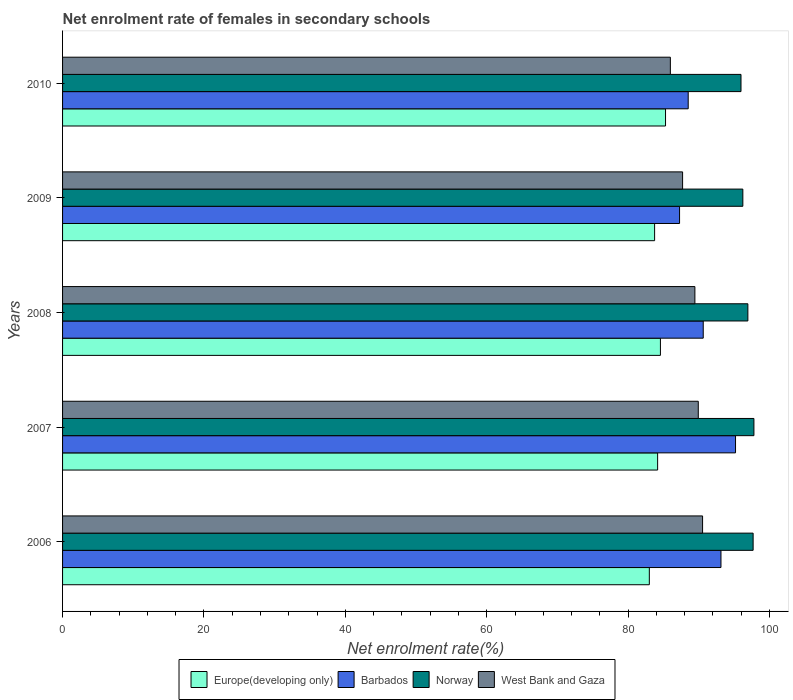How many different coloured bars are there?
Provide a succinct answer. 4. How many groups of bars are there?
Your answer should be compact. 5. Are the number of bars per tick equal to the number of legend labels?
Provide a succinct answer. Yes. Are the number of bars on each tick of the Y-axis equal?
Your response must be concise. Yes. How many bars are there on the 4th tick from the top?
Offer a very short reply. 4. What is the label of the 1st group of bars from the top?
Your response must be concise. 2010. In how many cases, is the number of bars for a given year not equal to the number of legend labels?
Provide a short and direct response. 0. What is the net enrolment rate of females in secondary schools in West Bank and Gaza in 2007?
Your answer should be compact. 89.92. Across all years, what is the maximum net enrolment rate of females in secondary schools in Norway?
Your answer should be compact. 97.79. Across all years, what is the minimum net enrolment rate of females in secondary schools in West Bank and Gaza?
Offer a terse response. 85.97. In which year was the net enrolment rate of females in secondary schools in Norway maximum?
Keep it short and to the point. 2007. In which year was the net enrolment rate of females in secondary schools in Europe(developing only) minimum?
Your answer should be very brief. 2006. What is the total net enrolment rate of females in secondary schools in Norway in the graph?
Give a very brief answer. 484.61. What is the difference between the net enrolment rate of females in secondary schools in West Bank and Gaza in 2006 and that in 2009?
Keep it short and to the point. 2.83. What is the difference between the net enrolment rate of females in secondary schools in Europe(developing only) in 2006 and the net enrolment rate of females in secondary schools in Norway in 2008?
Provide a short and direct response. -13.94. What is the average net enrolment rate of females in secondary schools in Norway per year?
Your response must be concise. 96.92. In the year 2008, what is the difference between the net enrolment rate of females in secondary schools in Barbados and net enrolment rate of females in secondary schools in West Bank and Gaza?
Make the answer very short. 1.18. In how many years, is the net enrolment rate of females in secondary schools in West Bank and Gaza greater than 12 %?
Give a very brief answer. 5. What is the ratio of the net enrolment rate of females in secondary schools in Norway in 2008 to that in 2009?
Give a very brief answer. 1.01. Is the difference between the net enrolment rate of females in secondary schools in Barbados in 2006 and 2010 greater than the difference between the net enrolment rate of females in secondary schools in West Bank and Gaza in 2006 and 2010?
Give a very brief answer. Yes. What is the difference between the highest and the second highest net enrolment rate of females in secondary schools in Europe(developing only)?
Offer a very short reply. 0.72. What is the difference between the highest and the lowest net enrolment rate of females in secondary schools in Norway?
Your answer should be compact. 1.83. In how many years, is the net enrolment rate of females in secondary schools in Barbados greater than the average net enrolment rate of females in secondary schools in Barbados taken over all years?
Give a very brief answer. 2. Is the sum of the net enrolment rate of females in secondary schools in Norway in 2008 and 2009 greater than the maximum net enrolment rate of females in secondary schools in Barbados across all years?
Provide a short and direct response. Yes. Is it the case that in every year, the sum of the net enrolment rate of females in secondary schools in Barbados and net enrolment rate of females in secondary schools in Norway is greater than the sum of net enrolment rate of females in secondary schools in West Bank and Gaza and net enrolment rate of females in secondary schools in Europe(developing only)?
Your response must be concise. Yes. What does the 2nd bar from the top in 2009 represents?
Keep it short and to the point. Norway. What does the 2nd bar from the bottom in 2010 represents?
Provide a short and direct response. Barbados. How many bars are there?
Ensure brevity in your answer.  20. How many legend labels are there?
Make the answer very short. 4. What is the title of the graph?
Ensure brevity in your answer.  Net enrolment rate of females in secondary schools. Does "Pacific island small states" appear as one of the legend labels in the graph?
Make the answer very short. No. What is the label or title of the X-axis?
Keep it short and to the point. Net enrolment rate(%). What is the label or title of the Y-axis?
Offer a very short reply. Years. What is the Net enrolment rate(%) in Europe(developing only) in 2006?
Make the answer very short. 83. What is the Net enrolment rate(%) of Barbados in 2006?
Your answer should be compact. 93.13. What is the Net enrolment rate(%) of Norway in 2006?
Your answer should be very brief. 97.68. What is the Net enrolment rate(%) of West Bank and Gaza in 2006?
Make the answer very short. 90.53. What is the Net enrolment rate(%) of Europe(developing only) in 2007?
Your response must be concise. 84.17. What is the Net enrolment rate(%) in Barbados in 2007?
Offer a terse response. 95.19. What is the Net enrolment rate(%) of Norway in 2007?
Provide a succinct answer. 97.79. What is the Net enrolment rate(%) of West Bank and Gaza in 2007?
Offer a very short reply. 89.92. What is the Net enrolment rate(%) of Europe(developing only) in 2008?
Make the answer very short. 84.57. What is the Net enrolment rate(%) of Barbados in 2008?
Give a very brief answer. 90.63. What is the Net enrolment rate(%) in Norway in 2008?
Provide a succinct answer. 96.94. What is the Net enrolment rate(%) in West Bank and Gaza in 2008?
Keep it short and to the point. 89.44. What is the Net enrolment rate(%) in Europe(developing only) in 2009?
Offer a terse response. 83.75. What is the Net enrolment rate(%) of Barbados in 2009?
Provide a short and direct response. 87.28. What is the Net enrolment rate(%) in Norway in 2009?
Give a very brief answer. 96.23. What is the Net enrolment rate(%) of West Bank and Gaza in 2009?
Keep it short and to the point. 87.71. What is the Net enrolment rate(%) of Europe(developing only) in 2010?
Provide a short and direct response. 85.29. What is the Net enrolment rate(%) of Barbados in 2010?
Your answer should be very brief. 88.5. What is the Net enrolment rate(%) in Norway in 2010?
Provide a short and direct response. 95.97. What is the Net enrolment rate(%) of West Bank and Gaza in 2010?
Keep it short and to the point. 85.97. Across all years, what is the maximum Net enrolment rate(%) of Europe(developing only)?
Provide a short and direct response. 85.29. Across all years, what is the maximum Net enrolment rate(%) in Barbados?
Make the answer very short. 95.19. Across all years, what is the maximum Net enrolment rate(%) in Norway?
Offer a terse response. 97.79. Across all years, what is the maximum Net enrolment rate(%) of West Bank and Gaza?
Ensure brevity in your answer.  90.53. Across all years, what is the minimum Net enrolment rate(%) in Europe(developing only)?
Offer a terse response. 83. Across all years, what is the minimum Net enrolment rate(%) in Barbados?
Your response must be concise. 87.28. Across all years, what is the minimum Net enrolment rate(%) in Norway?
Provide a short and direct response. 95.97. Across all years, what is the minimum Net enrolment rate(%) of West Bank and Gaza?
Your response must be concise. 85.97. What is the total Net enrolment rate(%) in Europe(developing only) in the graph?
Your answer should be compact. 420.78. What is the total Net enrolment rate(%) in Barbados in the graph?
Provide a short and direct response. 454.72. What is the total Net enrolment rate(%) in Norway in the graph?
Give a very brief answer. 484.61. What is the total Net enrolment rate(%) in West Bank and Gaza in the graph?
Keep it short and to the point. 443.58. What is the difference between the Net enrolment rate(%) in Europe(developing only) in 2006 and that in 2007?
Your response must be concise. -1.17. What is the difference between the Net enrolment rate(%) of Barbados in 2006 and that in 2007?
Offer a very short reply. -2.06. What is the difference between the Net enrolment rate(%) in Norway in 2006 and that in 2007?
Keep it short and to the point. -0.11. What is the difference between the Net enrolment rate(%) of West Bank and Gaza in 2006 and that in 2007?
Your answer should be compact. 0.61. What is the difference between the Net enrolment rate(%) of Europe(developing only) in 2006 and that in 2008?
Offer a very short reply. -1.57. What is the difference between the Net enrolment rate(%) of Barbados in 2006 and that in 2008?
Offer a very short reply. 2.51. What is the difference between the Net enrolment rate(%) of Norway in 2006 and that in 2008?
Give a very brief answer. 0.74. What is the difference between the Net enrolment rate(%) of West Bank and Gaza in 2006 and that in 2008?
Keep it short and to the point. 1.09. What is the difference between the Net enrolment rate(%) of Europe(developing only) in 2006 and that in 2009?
Keep it short and to the point. -0.75. What is the difference between the Net enrolment rate(%) in Barbados in 2006 and that in 2009?
Provide a succinct answer. 5.86. What is the difference between the Net enrolment rate(%) in Norway in 2006 and that in 2009?
Provide a short and direct response. 1.46. What is the difference between the Net enrolment rate(%) in West Bank and Gaza in 2006 and that in 2009?
Provide a succinct answer. 2.83. What is the difference between the Net enrolment rate(%) in Europe(developing only) in 2006 and that in 2010?
Ensure brevity in your answer.  -2.29. What is the difference between the Net enrolment rate(%) of Barbados in 2006 and that in 2010?
Ensure brevity in your answer.  4.63. What is the difference between the Net enrolment rate(%) in Norway in 2006 and that in 2010?
Give a very brief answer. 1.72. What is the difference between the Net enrolment rate(%) of West Bank and Gaza in 2006 and that in 2010?
Offer a very short reply. 4.56. What is the difference between the Net enrolment rate(%) of Europe(developing only) in 2007 and that in 2008?
Provide a short and direct response. -0.4. What is the difference between the Net enrolment rate(%) in Barbados in 2007 and that in 2008?
Your answer should be compact. 4.57. What is the difference between the Net enrolment rate(%) of Norway in 2007 and that in 2008?
Offer a very short reply. 0.86. What is the difference between the Net enrolment rate(%) of West Bank and Gaza in 2007 and that in 2008?
Provide a short and direct response. 0.48. What is the difference between the Net enrolment rate(%) of Europe(developing only) in 2007 and that in 2009?
Your answer should be very brief. 0.43. What is the difference between the Net enrolment rate(%) in Barbados in 2007 and that in 2009?
Provide a succinct answer. 7.92. What is the difference between the Net enrolment rate(%) of Norway in 2007 and that in 2009?
Give a very brief answer. 1.57. What is the difference between the Net enrolment rate(%) in West Bank and Gaza in 2007 and that in 2009?
Provide a short and direct response. 2.22. What is the difference between the Net enrolment rate(%) of Europe(developing only) in 2007 and that in 2010?
Offer a very short reply. -1.12. What is the difference between the Net enrolment rate(%) of Barbados in 2007 and that in 2010?
Provide a short and direct response. 6.69. What is the difference between the Net enrolment rate(%) in Norway in 2007 and that in 2010?
Offer a terse response. 1.83. What is the difference between the Net enrolment rate(%) in West Bank and Gaza in 2007 and that in 2010?
Make the answer very short. 3.95. What is the difference between the Net enrolment rate(%) of Europe(developing only) in 2008 and that in 2009?
Your answer should be compact. 0.82. What is the difference between the Net enrolment rate(%) in Barbados in 2008 and that in 2009?
Your response must be concise. 3.35. What is the difference between the Net enrolment rate(%) in Norway in 2008 and that in 2009?
Keep it short and to the point. 0.71. What is the difference between the Net enrolment rate(%) of West Bank and Gaza in 2008 and that in 2009?
Your response must be concise. 1.74. What is the difference between the Net enrolment rate(%) of Europe(developing only) in 2008 and that in 2010?
Ensure brevity in your answer.  -0.72. What is the difference between the Net enrolment rate(%) in Barbados in 2008 and that in 2010?
Keep it short and to the point. 2.13. What is the difference between the Net enrolment rate(%) in Norway in 2008 and that in 2010?
Offer a very short reply. 0.97. What is the difference between the Net enrolment rate(%) in West Bank and Gaza in 2008 and that in 2010?
Your answer should be very brief. 3.47. What is the difference between the Net enrolment rate(%) in Europe(developing only) in 2009 and that in 2010?
Provide a short and direct response. -1.54. What is the difference between the Net enrolment rate(%) in Barbados in 2009 and that in 2010?
Your answer should be compact. -1.22. What is the difference between the Net enrolment rate(%) of Norway in 2009 and that in 2010?
Offer a very short reply. 0.26. What is the difference between the Net enrolment rate(%) of West Bank and Gaza in 2009 and that in 2010?
Give a very brief answer. 1.73. What is the difference between the Net enrolment rate(%) of Europe(developing only) in 2006 and the Net enrolment rate(%) of Barbados in 2007?
Make the answer very short. -12.19. What is the difference between the Net enrolment rate(%) of Europe(developing only) in 2006 and the Net enrolment rate(%) of Norway in 2007?
Make the answer very short. -14.79. What is the difference between the Net enrolment rate(%) of Europe(developing only) in 2006 and the Net enrolment rate(%) of West Bank and Gaza in 2007?
Offer a very short reply. -6.93. What is the difference between the Net enrolment rate(%) of Barbados in 2006 and the Net enrolment rate(%) of Norway in 2007?
Offer a terse response. -4.66. What is the difference between the Net enrolment rate(%) in Barbados in 2006 and the Net enrolment rate(%) in West Bank and Gaza in 2007?
Give a very brief answer. 3.21. What is the difference between the Net enrolment rate(%) of Norway in 2006 and the Net enrolment rate(%) of West Bank and Gaza in 2007?
Ensure brevity in your answer.  7.76. What is the difference between the Net enrolment rate(%) in Europe(developing only) in 2006 and the Net enrolment rate(%) in Barbados in 2008?
Make the answer very short. -7.63. What is the difference between the Net enrolment rate(%) of Europe(developing only) in 2006 and the Net enrolment rate(%) of Norway in 2008?
Your answer should be very brief. -13.94. What is the difference between the Net enrolment rate(%) of Europe(developing only) in 2006 and the Net enrolment rate(%) of West Bank and Gaza in 2008?
Make the answer very short. -6.44. What is the difference between the Net enrolment rate(%) of Barbados in 2006 and the Net enrolment rate(%) of Norway in 2008?
Make the answer very short. -3.81. What is the difference between the Net enrolment rate(%) in Barbados in 2006 and the Net enrolment rate(%) in West Bank and Gaza in 2008?
Make the answer very short. 3.69. What is the difference between the Net enrolment rate(%) in Norway in 2006 and the Net enrolment rate(%) in West Bank and Gaza in 2008?
Ensure brevity in your answer.  8.24. What is the difference between the Net enrolment rate(%) in Europe(developing only) in 2006 and the Net enrolment rate(%) in Barbados in 2009?
Your response must be concise. -4.28. What is the difference between the Net enrolment rate(%) in Europe(developing only) in 2006 and the Net enrolment rate(%) in Norway in 2009?
Make the answer very short. -13.23. What is the difference between the Net enrolment rate(%) of Europe(developing only) in 2006 and the Net enrolment rate(%) of West Bank and Gaza in 2009?
Offer a terse response. -4.71. What is the difference between the Net enrolment rate(%) in Barbados in 2006 and the Net enrolment rate(%) in Norway in 2009?
Your response must be concise. -3.09. What is the difference between the Net enrolment rate(%) in Barbados in 2006 and the Net enrolment rate(%) in West Bank and Gaza in 2009?
Offer a terse response. 5.43. What is the difference between the Net enrolment rate(%) of Norway in 2006 and the Net enrolment rate(%) of West Bank and Gaza in 2009?
Offer a terse response. 9.98. What is the difference between the Net enrolment rate(%) in Europe(developing only) in 2006 and the Net enrolment rate(%) in Barbados in 2010?
Keep it short and to the point. -5.5. What is the difference between the Net enrolment rate(%) in Europe(developing only) in 2006 and the Net enrolment rate(%) in Norway in 2010?
Provide a succinct answer. -12.97. What is the difference between the Net enrolment rate(%) in Europe(developing only) in 2006 and the Net enrolment rate(%) in West Bank and Gaza in 2010?
Make the answer very short. -2.97. What is the difference between the Net enrolment rate(%) of Barbados in 2006 and the Net enrolment rate(%) of Norway in 2010?
Your answer should be very brief. -2.83. What is the difference between the Net enrolment rate(%) of Barbados in 2006 and the Net enrolment rate(%) of West Bank and Gaza in 2010?
Your response must be concise. 7.16. What is the difference between the Net enrolment rate(%) in Norway in 2006 and the Net enrolment rate(%) in West Bank and Gaza in 2010?
Ensure brevity in your answer.  11.71. What is the difference between the Net enrolment rate(%) in Europe(developing only) in 2007 and the Net enrolment rate(%) in Barbados in 2008?
Make the answer very short. -6.45. What is the difference between the Net enrolment rate(%) in Europe(developing only) in 2007 and the Net enrolment rate(%) in Norway in 2008?
Keep it short and to the point. -12.77. What is the difference between the Net enrolment rate(%) in Europe(developing only) in 2007 and the Net enrolment rate(%) in West Bank and Gaza in 2008?
Make the answer very short. -5.27. What is the difference between the Net enrolment rate(%) in Barbados in 2007 and the Net enrolment rate(%) in Norway in 2008?
Your answer should be very brief. -1.75. What is the difference between the Net enrolment rate(%) of Barbados in 2007 and the Net enrolment rate(%) of West Bank and Gaza in 2008?
Offer a terse response. 5.75. What is the difference between the Net enrolment rate(%) of Norway in 2007 and the Net enrolment rate(%) of West Bank and Gaza in 2008?
Your answer should be very brief. 8.35. What is the difference between the Net enrolment rate(%) in Europe(developing only) in 2007 and the Net enrolment rate(%) in Barbados in 2009?
Ensure brevity in your answer.  -3.1. What is the difference between the Net enrolment rate(%) of Europe(developing only) in 2007 and the Net enrolment rate(%) of Norway in 2009?
Offer a very short reply. -12.05. What is the difference between the Net enrolment rate(%) in Europe(developing only) in 2007 and the Net enrolment rate(%) in West Bank and Gaza in 2009?
Your response must be concise. -3.53. What is the difference between the Net enrolment rate(%) of Barbados in 2007 and the Net enrolment rate(%) of Norway in 2009?
Keep it short and to the point. -1.03. What is the difference between the Net enrolment rate(%) of Barbados in 2007 and the Net enrolment rate(%) of West Bank and Gaza in 2009?
Offer a terse response. 7.49. What is the difference between the Net enrolment rate(%) of Norway in 2007 and the Net enrolment rate(%) of West Bank and Gaza in 2009?
Provide a succinct answer. 10.09. What is the difference between the Net enrolment rate(%) of Europe(developing only) in 2007 and the Net enrolment rate(%) of Barbados in 2010?
Provide a succinct answer. -4.33. What is the difference between the Net enrolment rate(%) of Europe(developing only) in 2007 and the Net enrolment rate(%) of Norway in 2010?
Offer a terse response. -11.79. What is the difference between the Net enrolment rate(%) in Europe(developing only) in 2007 and the Net enrolment rate(%) in West Bank and Gaza in 2010?
Offer a terse response. -1.8. What is the difference between the Net enrolment rate(%) of Barbados in 2007 and the Net enrolment rate(%) of Norway in 2010?
Provide a succinct answer. -0.77. What is the difference between the Net enrolment rate(%) of Barbados in 2007 and the Net enrolment rate(%) of West Bank and Gaza in 2010?
Your answer should be very brief. 9.22. What is the difference between the Net enrolment rate(%) in Norway in 2007 and the Net enrolment rate(%) in West Bank and Gaza in 2010?
Make the answer very short. 11.82. What is the difference between the Net enrolment rate(%) of Europe(developing only) in 2008 and the Net enrolment rate(%) of Barbados in 2009?
Provide a short and direct response. -2.71. What is the difference between the Net enrolment rate(%) in Europe(developing only) in 2008 and the Net enrolment rate(%) in Norway in 2009?
Your answer should be very brief. -11.66. What is the difference between the Net enrolment rate(%) of Europe(developing only) in 2008 and the Net enrolment rate(%) of West Bank and Gaza in 2009?
Provide a short and direct response. -3.14. What is the difference between the Net enrolment rate(%) of Barbados in 2008 and the Net enrolment rate(%) of Norway in 2009?
Offer a very short reply. -5.6. What is the difference between the Net enrolment rate(%) of Barbados in 2008 and the Net enrolment rate(%) of West Bank and Gaza in 2009?
Ensure brevity in your answer.  2.92. What is the difference between the Net enrolment rate(%) of Norway in 2008 and the Net enrolment rate(%) of West Bank and Gaza in 2009?
Your answer should be compact. 9.23. What is the difference between the Net enrolment rate(%) of Europe(developing only) in 2008 and the Net enrolment rate(%) of Barbados in 2010?
Keep it short and to the point. -3.93. What is the difference between the Net enrolment rate(%) of Europe(developing only) in 2008 and the Net enrolment rate(%) of Norway in 2010?
Provide a succinct answer. -11.4. What is the difference between the Net enrolment rate(%) in Europe(developing only) in 2008 and the Net enrolment rate(%) in West Bank and Gaza in 2010?
Offer a terse response. -1.41. What is the difference between the Net enrolment rate(%) of Barbados in 2008 and the Net enrolment rate(%) of Norway in 2010?
Make the answer very short. -5.34. What is the difference between the Net enrolment rate(%) in Barbados in 2008 and the Net enrolment rate(%) in West Bank and Gaza in 2010?
Offer a very short reply. 4.65. What is the difference between the Net enrolment rate(%) in Norway in 2008 and the Net enrolment rate(%) in West Bank and Gaza in 2010?
Ensure brevity in your answer.  10.96. What is the difference between the Net enrolment rate(%) of Europe(developing only) in 2009 and the Net enrolment rate(%) of Barbados in 2010?
Make the answer very short. -4.75. What is the difference between the Net enrolment rate(%) of Europe(developing only) in 2009 and the Net enrolment rate(%) of Norway in 2010?
Keep it short and to the point. -12.22. What is the difference between the Net enrolment rate(%) in Europe(developing only) in 2009 and the Net enrolment rate(%) in West Bank and Gaza in 2010?
Provide a short and direct response. -2.23. What is the difference between the Net enrolment rate(%) of Barbados in 2009 and the Net enrolment rate(%) of Norway in 2010?
Keep it short and to the point. -8.69. What is the difference between the Net enrolment rate(%) in Barbados in 2009 and the Net enrolment rate(%) in West Bank and Gaza in 2010?
Ensure brevity in your answer.  1.3. What is the difference between the Net enrolment rate(%) in Norway in 2009 and the Net enrolment rate(%) in West Bank and Gaza in 2010?
Keep it short and to the point. 10.25. What is the average Net enrolment rate(%) in Europe(developing only) per year?
Your response must be concise. 84.16. What is the average Net enrolment rate(%) of Barbados per year?
Provide a short and direct response. 90.94. What is the average Net enrolment rate(%) in Norway per year?
Keep it short and to the point. 96.92. What is the average Net enrolment rate(%) of West Bank and Gaza per year?
Your answer should be compact. 88.72. In the year 2006, what is the difference between the Net enrolment rate(%) of Europe(developing only) and Net enrolment rate(%) of Barbados?
Make the answer very short. -10.13. In the year 2006, what is the difference between the Net enrolment rate(%) in Europe(developing only) and Net enrolment rate(%) in Norway?
Your answer should be compact. -14.68. In the year 2006, what is the difference between the Net enrolment rate(%) in Europe(developing only) and Net enrolment rate(%) in West Bank and Gaza?
Your response must be concise. -7.53. In the year 2006, what is the difference between the Net enrolment rate(%) of Barbados and Net enrolment rate(%) of Norway?
Provide a short and direct response. -4.55. In the year 2006, what is the difference between the Net enrolment rate(%) of Barbados and Net enrolment rate(%) of West Bank and Gaza?
Your answer should be compact. 2.6. In the year 2006, what is the difference between the Net enrolment rate(%) in Norway and Net enrolment rate(%) in West Bank and Gaza?
Keep it short and to the point. 7.15. In the year 2007, what is the difference between the Net enrolment rate(%) in Europe(developing only) and Net enrolment rate(%) in Barbados?
Ensure brevity in your answer.  -11.02. In the year 2007, what is the difference between the Net enrolment rate(%) in Europe(developing only) and Net enrolment rate(%) in Norway?
Make the answer very short. -13.62. In the year 2007, what is the difference between the Net enrolment rate(%) in Europe(developing only) and Net enrolment rate(%) in West Bank and Gaza?
Give a very brief answer. -5.75. In the year 2007, what is the difference between the Net enrolment rate(%) in Barbados and Net enrolment rate(%) in Norway?
Your answer should be compact. -2.6. In the year 2007, what is the difference between the Net enrolment rate(%) of Barbados and Net enrolment rate(%) of West Bank and Gaza?
Offer a very short reply. 5.27. In the year 2007, what is the difference between the Net enrolment rate(%) in Norway and Net enrolment rate(%) in West Bank and Gaza?
Keep it short and to the point. 7.87. In the year 2008, what is the difference between the Net enrolment rate(%) in Europe(developing only) and Net enrolment rate(%) in Barbados?
Your response must be concise. -6.06. In the year 2008, what is the difference between the Net enrolment rate(%) of Europe(developing only) and Net enrolment rate(%) of Norway?
Give a very brief answer. -12.37. In the year 2008, what is the difference between the Net enrolment rate(%) in Europe(developing only) and Net enrolment rate(%) in West Bank and Gaza?
Your answer should be compact. -4.87. In the year 2008, what is the difference between the Net enrolment rate(%) in Barbados and Net enrolment rate(%) in Norway?
Ensure brevity in your answer.  -6.31. In the year 2008, what is the difference between the Net enrolment rate(%) of Barbados and Net enrolment rate(%) of West Bank and Gaza?
Your response must be concise. 1.18. In the year 2008, what is the difference between the Net enrolment rate(%) in Norway and Net enrolment rate(%) in West Bank and Gaza?
Give a very brief answer. 7.49. In the year 2009, what is the difference between the Net enrolment rate(%) in Europe(developing only) and Net enrolment rate(%) in Barbados?
Your answer should be compact. -3.53. In the year 2009, what is the difference between the Net enrolment rate(%) of Europe(developing only) and Net enrolment rate(%) of Norway?
Provide a short and direct response. -12.48. In the year 2009, what is the difference between the Net enrolment rate(%) of Europe(developing only) and Net enrolment rate(%) of West Bank and Gaza?
Give a very brief answer. -3.96. In the year 2009, what is the difference between the Net enrolment rate(%) of Barbados and Net enrolment rate(%) of Norway?
Offer a very short reply. -8.95. In the year 2009, what is the difference between the Net enrolment rate(%) of Barbados and Net enrolment rate(%) of West Bank and Gaza?
Keep it short and to the point. -0.43. In the year 2009, what is the difference between the Net enrolment rate(%) of Norway and Net enrolment rate(%) of West Bank and Gaza?
Ensure brevity in your answer.  8.52. In the year 2010, what is the difference between the Net enrolment rate(%) of Europe(developing only) and Net enrolment rate(%) of Barbados?
Your answer should be compact. -3.21. In the year 2010, what is the difference between the Net enrolment rate(%) of Europe(developing only) and Net enrolment rate(%) of Norway?
Make the answer very short. -10.68. In the year 2010, what is the difference between the Net enrolment rate(%) in Europe(developing only) and Net enrolment rate(%) in West Bank and Gaza?
Your response must be concise. -0.68. In the year 2010, what is the difference between the Net enrolment rate(%) of Barbados and Net enrolment rate(%) of Norway?
Your answer should be compact. -7.47. In the year 2010, what is the difference between the Net enrolment rate(%) in Barbados and Net enrolment rate(%) in West Bank and Gaza?
Make the answer very short. 2.52. In the year 2010, what is the difference between the Net enrolment rate(%) in Norway and Net enrolment rate(%) in West Bank and Gaza?
Provide a succinct answer. 9.99. What is the ratio of the Net enrolment rate(%) of Europe(developing only) in 2006 to that in 2007?
Provide a succinct answer. 0.99. What is the ratio of the Net enrolment rate(%) in Barbados in 2006 to that in 2007?
Provide a succinct answer. 0.98. What is the ratio of the Net enrolment rate(%) of West Bank and Gaza in 2006 to that in 2007?
Your response must be concise. 1.01. What is the ratio of the Net enrolment rate(%) of Europe(developing only) in 2006 to that in 2008?
Keep it short and to the point. 0.98. What is the ratio of the Net enrolment rate(%) in Barbados in 2006 to that in 2008?
Your response must be concise. 1.03. What is the ratio of the Net enrolment rate(%) of Norway in 2006 to that in 2008?
Ensure brevity in your answer.  1.01. What is the ratio of the Net enrolment rate(%) of West Bank and Gaza in 2006 to that in 2008?
Offer a terse response. 1.01. What is the ratio of the Net enrolment rate(%) in Barbados in 2006 to that in 2009?
Make the answer very short. 1.07. What is the ratio of the Net enrolment rate(%) of Norway in 2006 to that in 2009?
Give a very brief answer. 1.02. What is the ratio of the Net enrolment rate(%) in West Bank and Gaza in 2006 to that in 2009?
Keep it short and to the point. 1.03. What is the ratio of the Net enrolment rate(%) in Europe(developing only) in 2006 to that in 2010?
Your answer should be compact. 0.97. What is the ratio of the Net enrolment rate(%) of Barbados in 2006 to that in 2010?
Provide a short and direct response. 1.05. What is the ratio of the Net enrolment rate(%) in Norway in 2006 to that in 2010?
Ensure brevity in your answer.  1.02. What is the ratio of the Net enrolment rate(%) of West Bank and Gaza in 2006 to that in 2010?
Your response must be concise. 1.05. What is the ratio of the Net enrolment rate(%) of Europe(developing only) in 2007 to that in 2008?
Make the answer very short. 1. What is the ratio of the Net enrolment rate(%) of Barbados in 2007 to that in 2008?
Offer a terse response. 1.05. What is the ratio of the Net enrolment rate(%) in Norway in 2007 to that in 2008?
Keep it short and to the point. 1.01. What is the ratio of the Net enrolment rate(%) of West Bank and Gaza in 2007 to that in 2008?
Ensure brevity in your answer.  1.01. What is the ratio of the Net enrolment rate(%) of Europe(developing only) in 2007 to that in 2009?
Provide a short and direct response. 1.01. What is the ratio of the Net enrolment rate(%) of Barbados in 2007 to that in 2009?
Your answer should be very brief. 1.09. What is the ratio of the Net enrolment rate(%) of Norway in 2007 to that in 2009?
Your answer should be very brief. 1.02. What is the ratio of the Net enrolment rate(%) in West Bank and Gaza in 2007 to that in 2009?
Offer a very short reply. 1.03. What is the ratio of the Net enrolment rate(%) in Europe(developing only) in 2007 to that in 2010?
Provide a succinct answer. 0.99. What is the ratio of the Net enrolment rate(%) of Barbados in 2007 to that in 2010?
Your response must be concise. 1.08. What is the ratio of the Net enrolment rate(%) in Norway in 2007 to that in 2010?
Provide a short and direct response. 1.02. What is the ratio of the Net enrolment rate(%) of West Bank and Gaza in 2007 to that in 2010?
Give a very brief answer. 1.05. What is the ratio of the Net enrolment rate(%) in Europe(developing only) in 2008 to that in 2009?
Your answer should be very brief. 1.01. What is the ratio of the Net enrolment rate(%) in Barbados in 2008 to that in 2009?
Offer a very short reply. 1.04. What is the ratio of the Net enrolment rate(%) of Norway in 2008 to that in 2009?
Your response must be concise. 1.01. What is the ratio of the Net enrolment rate(%) in West Bank and Gaza in 2008 to that in 2009?
Your response must be concise. 1.02. What is the ratio of the Net enrolment rate(%) of Europe(developing only) in 2008 to that in 2010?
Your answer should be compact. 0.99. What is the ratio of the Net enrolment rate(%) of Barbados in 2008 to that in 2010?
Your response must be concise. 1.02. What is the ratio of the Net enrolment rate(%) in West Bank and Gaza in 2008 to that in 2010?
Provide a short and direct response. 1.04. What is the ratio of the Net enrolment rate(%) of Europe(developing only) in 2009 to that in 2010?
Provide a short and direct response. 0.98. What is the ratio of the Net enrolment rate(%) of Barbados in 2009 to that in 2010?
Ensure brevity in your answer.  0.99. What is the ratio of the Net enrolment rate(%) in Norway in 2009 to that in 2010?
Your answer should be compact. 1. What is the ratio of the Net enrolment rate(%) in West Bank and Gaza in 2009 to that in 2010?
Keep it short and to the point. 1.02. What is the difference between the highest and the second highest Net enrolment rate(%) in Europe(developing only)?
Your response must be concise. 0.72. What is the difference between the highest and the second highest Net enrolment rate(%) of Barbados?
Make the answer very short. 2.06. What is the difference between the highest and the second highest Net enrolment rate(%) of Norway?
Give a very brief answer. 0.11. What is the difference between the highest and the second highest Net enrolment rate(%) in West Bank and Gaza?
Offer a terse response. 0.61. What is the difference between the highest and the lowest Net enrolment rate(%) in Europe(developing only)?
Keep it short and to the point. 2.29. What is the difference between the highest and the lowest Net enrolment rate(%) of Barbados?
Offer a terse response. 7.92. What is the difference between the highest and the lowest Net enrolment rate(%) in Norway?
Keep it short and to the point. 1.83. What is the difference between the highest and the lowest Net enrolment rate(%) in West Bank and Gaza?
Offer a very short reply. 4.56. 